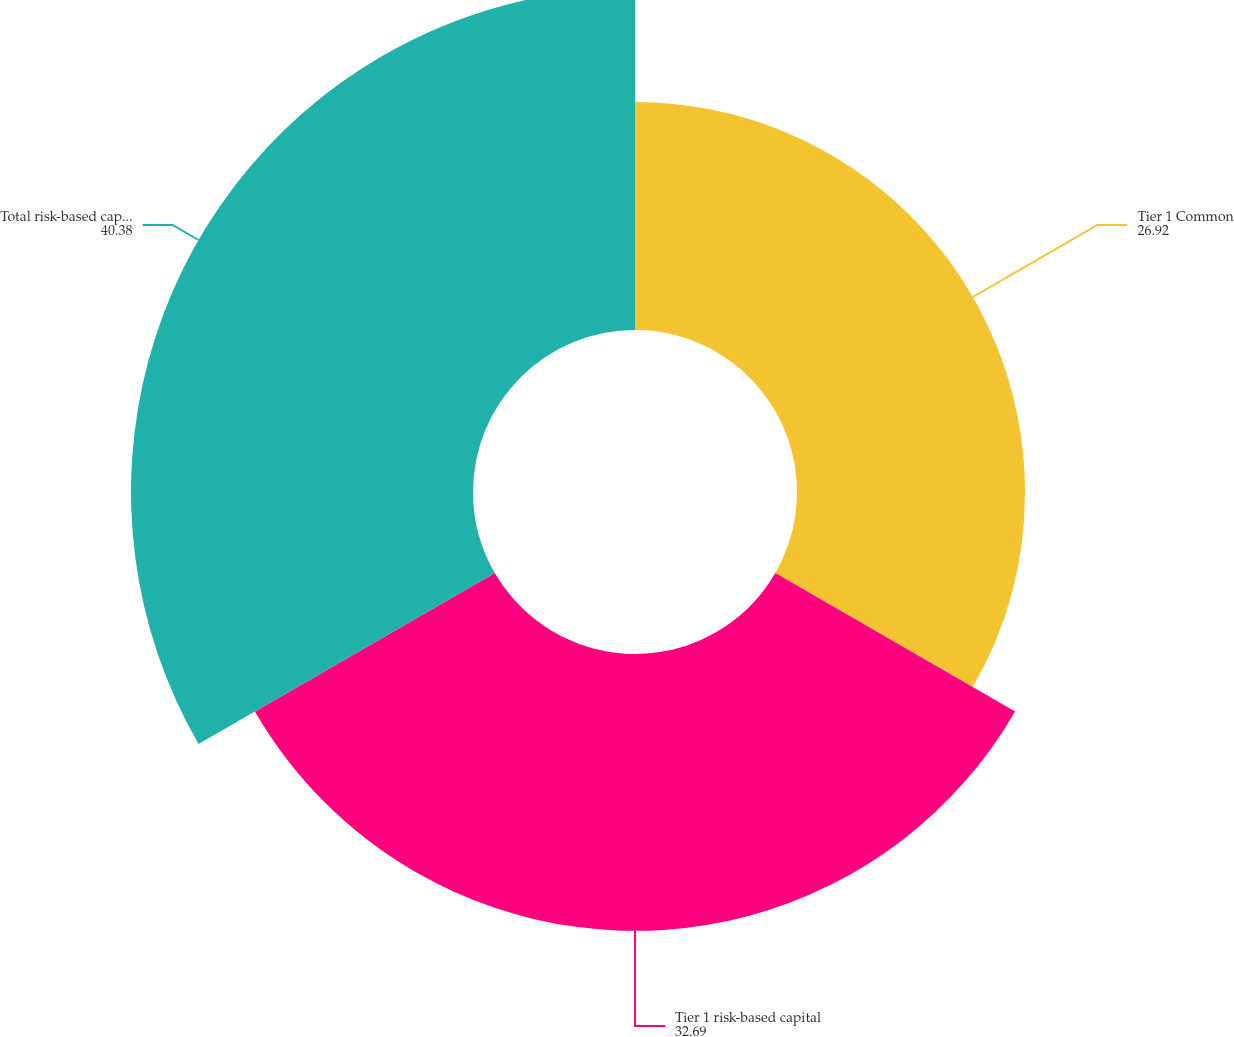Convert chart. <chart><loc_0><loc_0><loc_500><loc_500><pie_chart><fcel>Tier 1 Common<fcel>Tier 1 risk-based capital<fcel>Total risk-based capital ratio<nl><fcel>26.92%<fcel>32.69%<fcel>40.38%<nl></chart> 